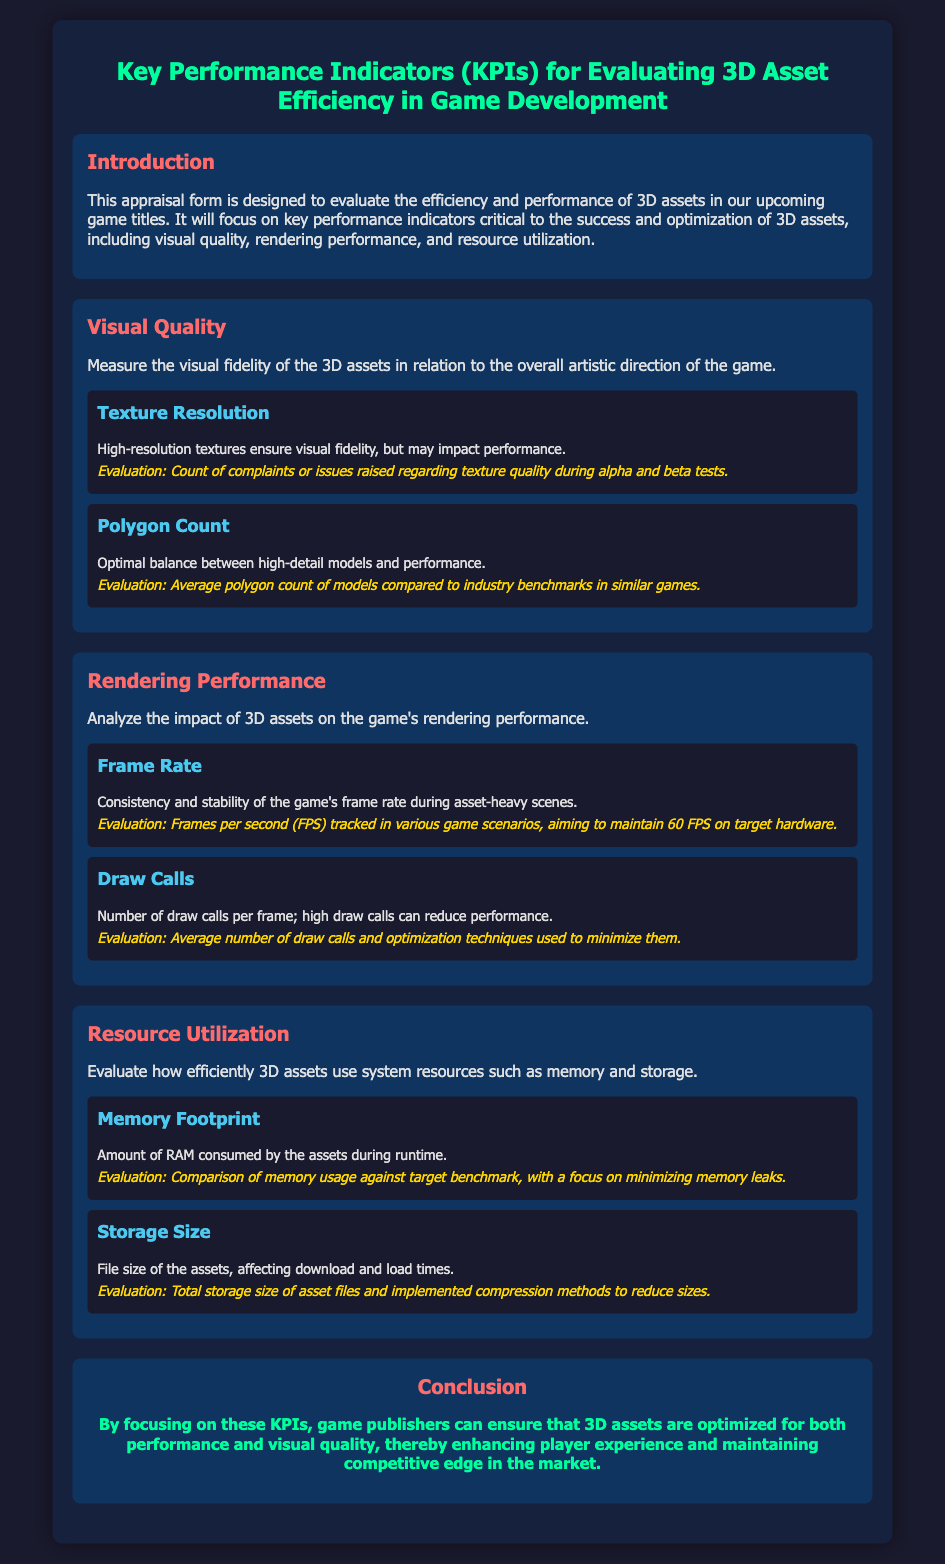What is the main focus of the appraisal form? The appraisal form is designed to evaluate the efficiency and performance of 3D assets in game development.
Answer: 3D assets efficiency and performance What is the evaluation criterion for Texture Resolution? The evaluation criterion for Texture Resolution is the count of complaints or issues raised regarding texture quality during testing phases.
Answer: Count of complaints What is the target frame rate aimed for in the Rendering Performance section? The target frame rate aimed for is 60 FPS on target hardware during various game scenarios.
Answer: 60 FPS What does the Memory Footprint measure? Memory Footprint measures the amount of RAM consumed by the assets during runtime.
Answer: RAM consumed What is the purpose of analyzing Draw Calls? The purpose is to evaluate the number of draw calls per frame and understand their impact on performance.
Answer: Number of draw calls What does the Storage Size impact according to the appraisal form? The Storage Size impacts download and load times for the assets in the game.
Answer: Download and load times What is the average polygon count evaluated against? The average polygon count is evaluated against industry benchmarks in similar games.
Answer: Industry benchmarks What color is used for the title of each section? The title of each section is colored in a shade of pink, specifically #ff6b6b.
Answer: Pink What is one optimization technique related to Minimizing Draw Calls? The form mentions the use of optimization techniques to minimize the average number of draw calls.
Answer: Optimization techniques 